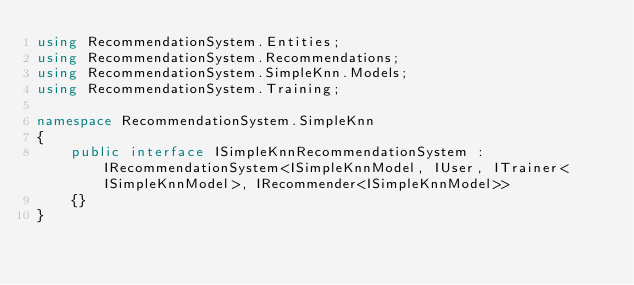Convert code to text. <code><loc_0><loc_0><loc_500><loc_500><_C#_>using RecommendationSystem.Entities;
using RecommendationSystem.Recommendations;
using RecommendationSystem.SimpleKnn.Models;
using RecommendationSystem.Training;

namespace RecommendationSystem.SimpleKnn
{
    public interface ISimpleKnnRecommendationSystem : IRecommendationSystem<ISimpleKnnModel, IUser, ITrainer<ISimpleKnnModel>, IRecommender<ISimpleKnnModel>>
    {}
}</code> 